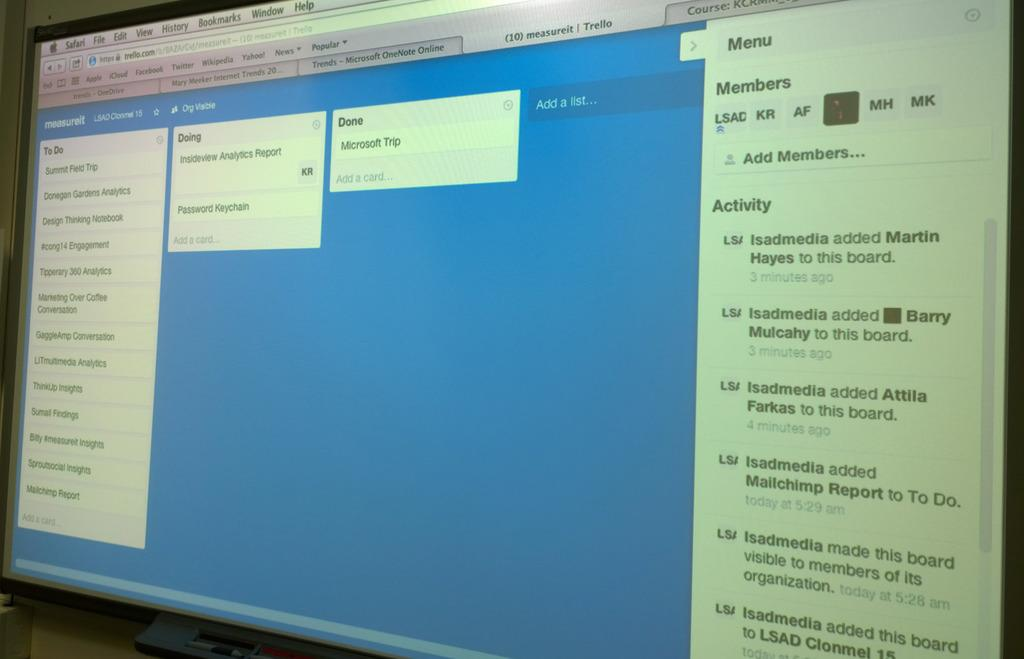<image>
Describe the image concisely. A computer screen displays a page that says measureit at the top left. 